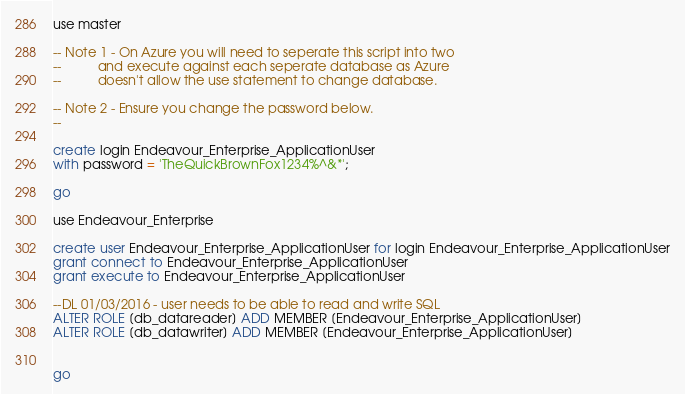<code> <loc_0><loc_0><loc_500><loc_500><_SQL_>use master

-- Note 1 - On Azure you will need to seperate this script into two
--          and execute against each seperate database as Azure
--          doesn't allow the use statement to change database.

-- Note 2 - Ensure you change the password below.
--

create login Endeavour_Enterprise_ApplicationUser
with password = 'TheQuickBrownFox1234%^&*';

go

use Endeavour_Enterprise

create user Endeavour_Enterprise_ApplicationUser for login Endeavour_Enterprise_ApplicationUser
grant connect to Endeavour_Enterprise_ApplicationUser
grant execute to Endeavour_Enterprise_ApplicationUser

--DL 01/03/2016 - user needs to be able to read and write SQL
ALTER ROLE [db_datareader] ADD MEMBER [Endeavour_Enterprise_ApplicationUser]
ALTER ROLE [db_datawriter] ADD MEMBER [Endeavour_Enterprise_ApplicationUser]


go</code> 